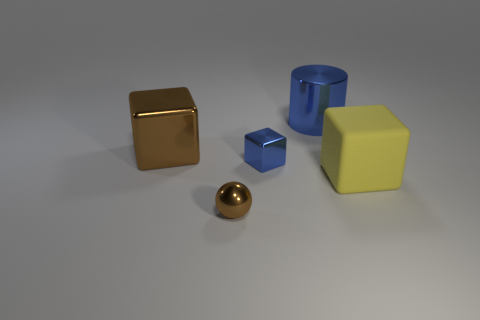Add 3 tiny yellow matte spheres. How many objects exist? 8 Subtract all spheres. How many objects are left? 4 Subtract all large cubes. Subtract all yellow objects. How many objects are left? 2 Add 4 small metal objects. How many small metal objects are left? 6 Add 3 big shiny cylinders. How many big shiny cylinders exist? 4 Subtract 0 red cubes. How many objects are left? 5 